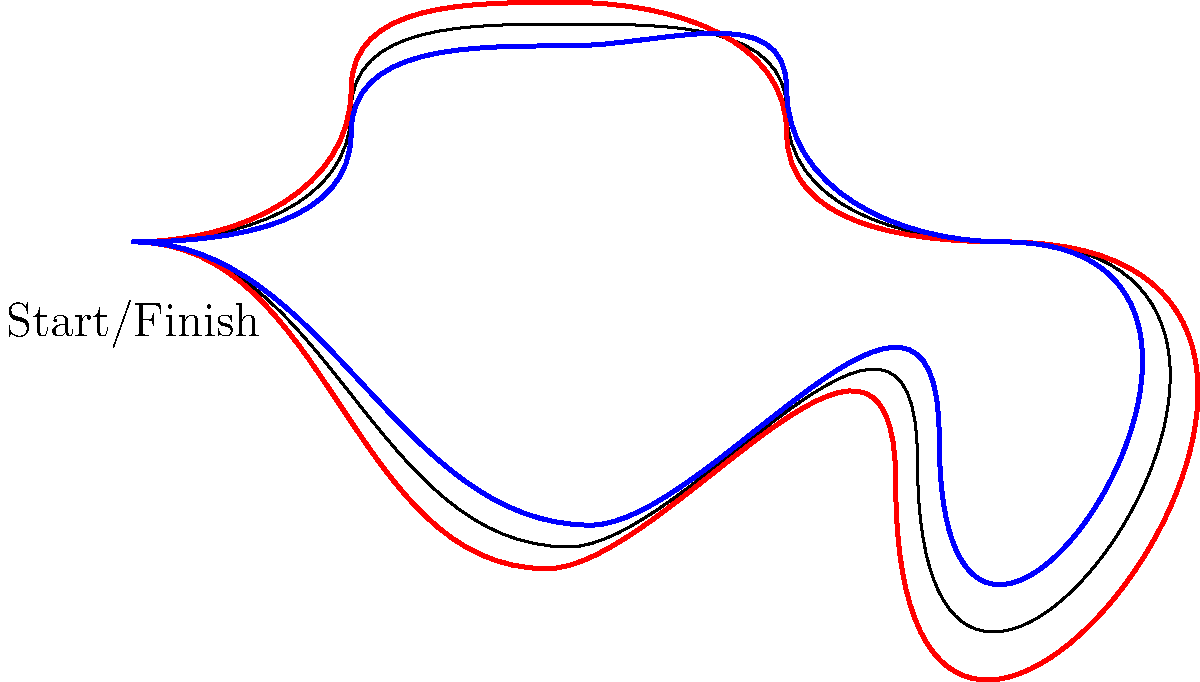Based on the race trajectories shown for Driver A (red) and Driver B (blue) on this circuit map, which driver is likely to have the advantage in the first sector of the lap, and why? To determine which driver has the advantage in the first sector, we need to analyze their trajectories:

1. The first sector typically comprises the start/finish straight and the first few corners.

2. Observe that Driver A (red line) takes a wider entry into the first corner, maintaining a higher line through the subsequent turns.

3. Driver B (blue line) takes a tighter line through the first corner and the following sequence.

4. A wider entry and higher line through corners often allow for:
   a) Higher entry speeds
   b) Better maintenance of momentum
   c) Earlier acceleration out of corners

5. While Driver B's tighter line might seem shorter, it often requires more braking and a later acceleration point.

6. In high-speed corners, which the first sector appears to have, a wider line like Driver A's is generally faster as it allows for higher minimum cornering speeds.

7. Driver A's line suggests a more aggressive, speed-carrying approach, which is typically advantageous in the opening sector of a lap where maintaining momentum is crucial.

Given these observations, Driver A's racing line through the first sector is likely to yield a time advantage, as it prioritizes speed and momentum over a shorter distance.
Answer: Driver A, due to wider entry and higher line maintaining more speed through corners. 